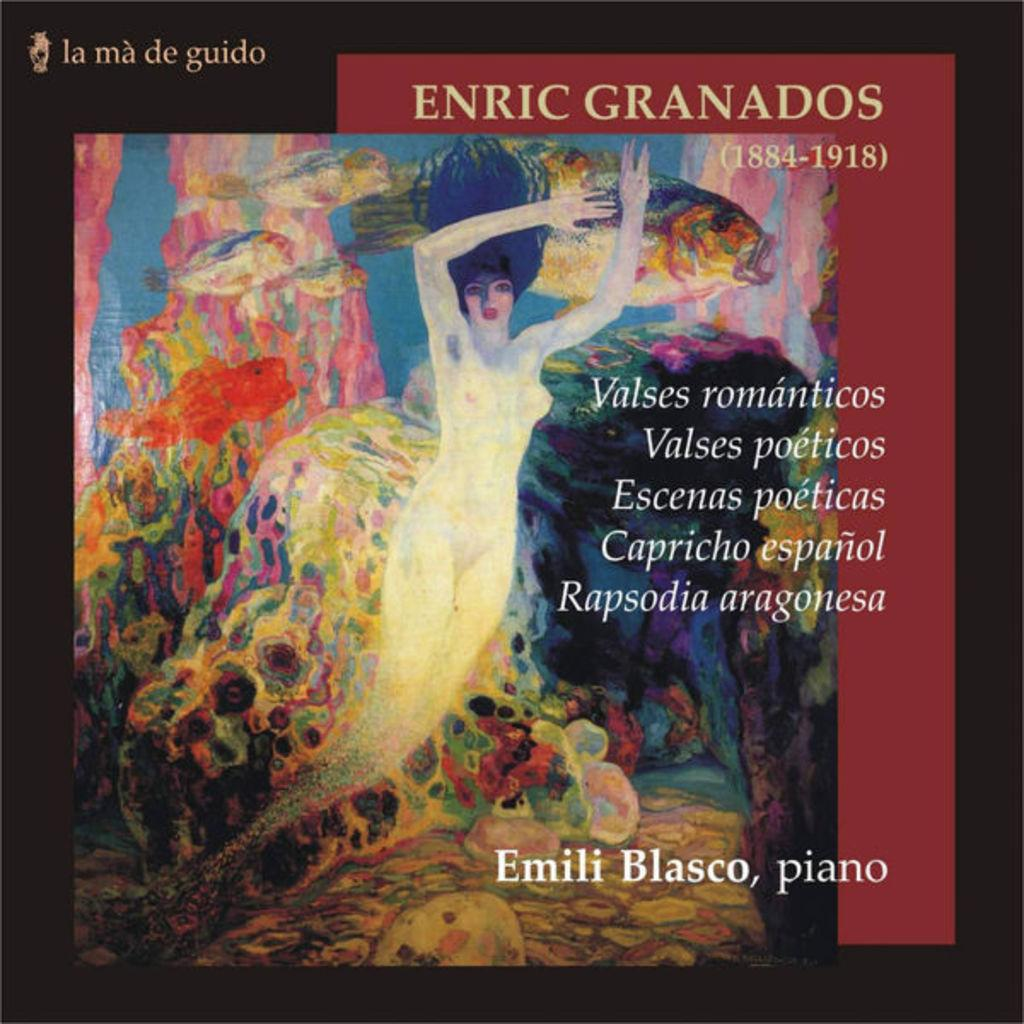<image>
Summarize the visual content of the image. La ma de guido logo for Enric Grandos by Emili blasco piano. 